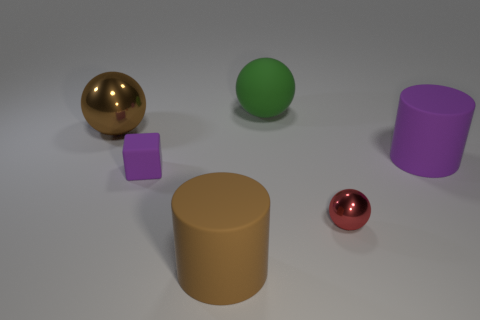Subtract all large metal spheres. How many spheres are left? 2 Add 2 tiny yellow rubber spheres. How many objects exist? 8 Subtract 1 balls. How many balls are left? 2 Subtract all purple cylinders. How many cylinders are left? 1 Add 4 rubber objects. How many rubber objects are left? 8 Add 2 small red matte blocks. How many small red matte blocks exist? 2 Subtract 0 gray blocks. How many objects are left? 6 Subtract all cubes. How many objects are left? 5 Subtract all blue balls. Subtract all cyan blocks. How many balls are left? 3 Subtract all red spheres. How many blue cubes are left? 0 